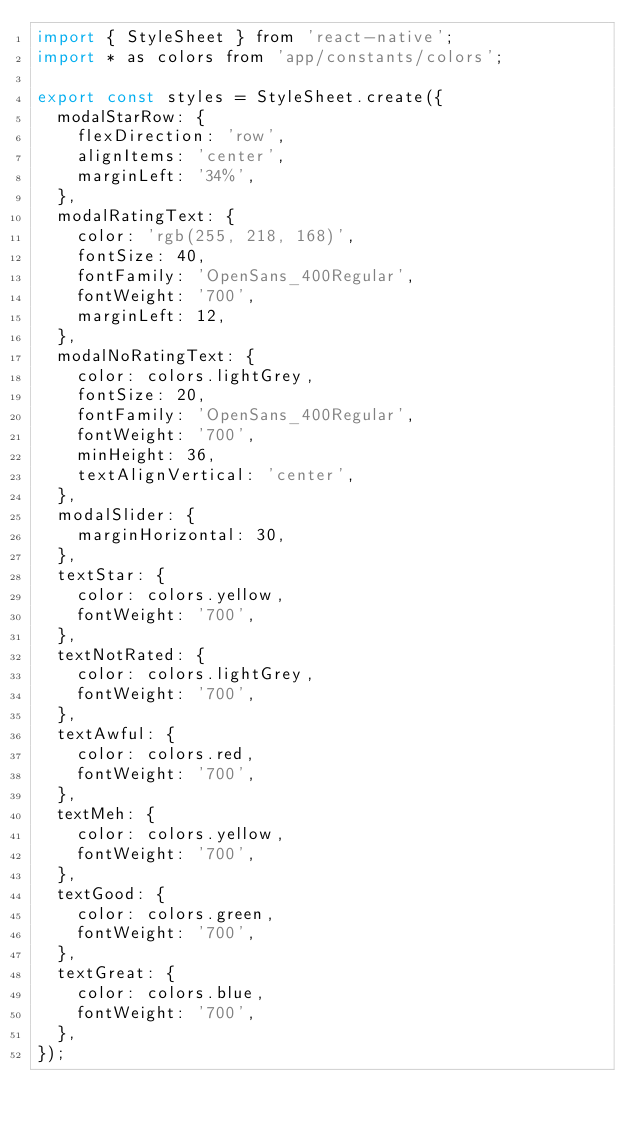<code> <loc_0><loc_0><loc_500><loc_500><_JavaScript_>import { StyleSheet } from 'react-native';
import * as colors from 'app/constants/colors';

export const styles = StyleSheet.create({
  modalStarRow: {
    flexDirection: 'row',
    alignItems: 'center',
    marginLeft: '34%',
  },
  modalRatingText: {
    color: 'rgb(255, 218, 168)',
    fontSize: 40,
    fontFamily: 'OpenSans_400Regular',
    fontWeight: '700',
    marginLeft: 12,
  },
  modalNoRatingText: {
    color: colors.lightGrey,
    fontSize: 20,
    fontFamily: 'OpenSans_400Regular',
    fontWeight: '700',
    minHeight: 36,
    textAlignVertical: 'center',
  },
  modalSlider: {
    marginHorizontal: 30,
  },
  textStar: {
    color: colors.yellow,
    fontWeight: '700',
  },
  textNotRated: {
    color: colors.lightGrey,
    fontWeight: '700',
  },
  textAwful: {
    color: colors.red,
    fontWeight: '700',
  },
  textMeh: {
    color: colors.yellow,
    fontWeight: '700',
  },
  textGood: {
    color: colors.green,
    fontWeight: '700',
  },
  textGreat: {
    color: colors.blue,
    fontWeight: '700',
  },
});
</code> 